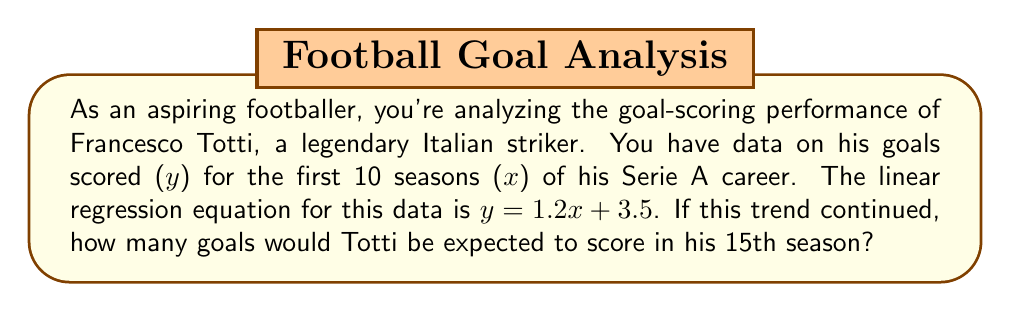Could you help me with this problem? Let's approach this step-by-step:

1) The linear regression equation is given as:
   $y = 1.2x + 3.5$

   Where:
   $y$ = number of goals
   $x$ = season number

2) We need to find $y$ when $x = 15$ (15th season)

3) Substitute $x = 15$ into the equation:
   $y = 1.2(15) + 3.5$

4) Calculate:
   $y = 18 + 3.5$
   $y = 21.5$

5) Since we're dealing with goals, which must be whole numbers, we round to the nearest integer:
   $y \approx 22$

Therefore, if the trend continued, Totti would be expected to score approximately 22 goals in his 15th season.
Answer: 22 goals 